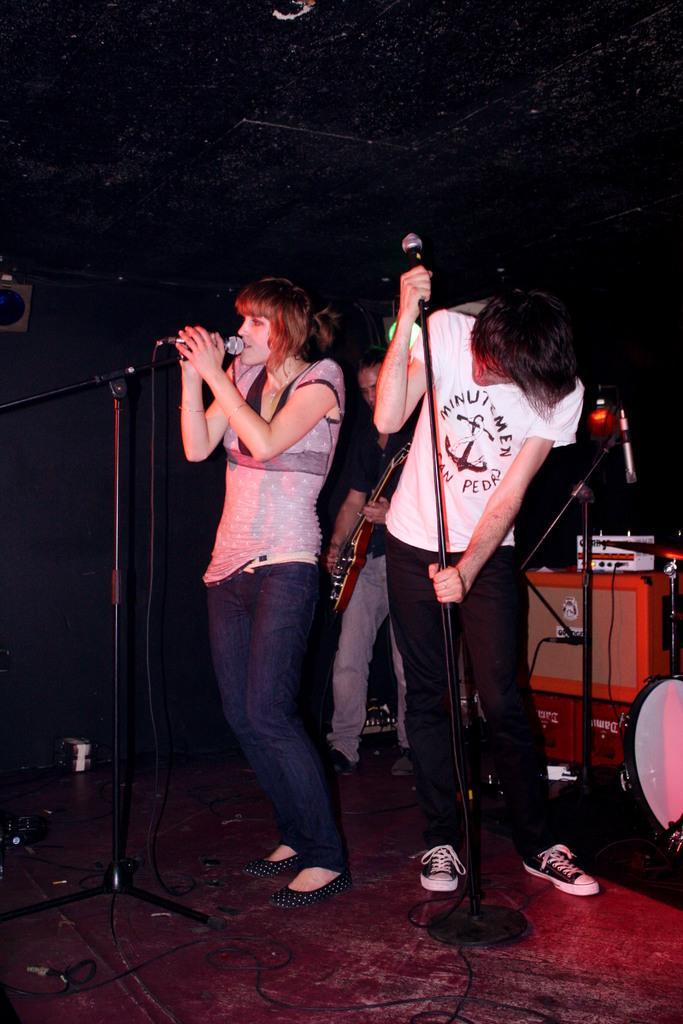Can you describe this image briefly? In this picture there is a woman standing holding the microphone with both of her hands and she is singing, this a man beside her is standing looking at the microphone stand holding it with his left hand and holding a microphone with his right hand. In the backdrop there is a person who is playing the guitar and there is a music equipment kept on the table 